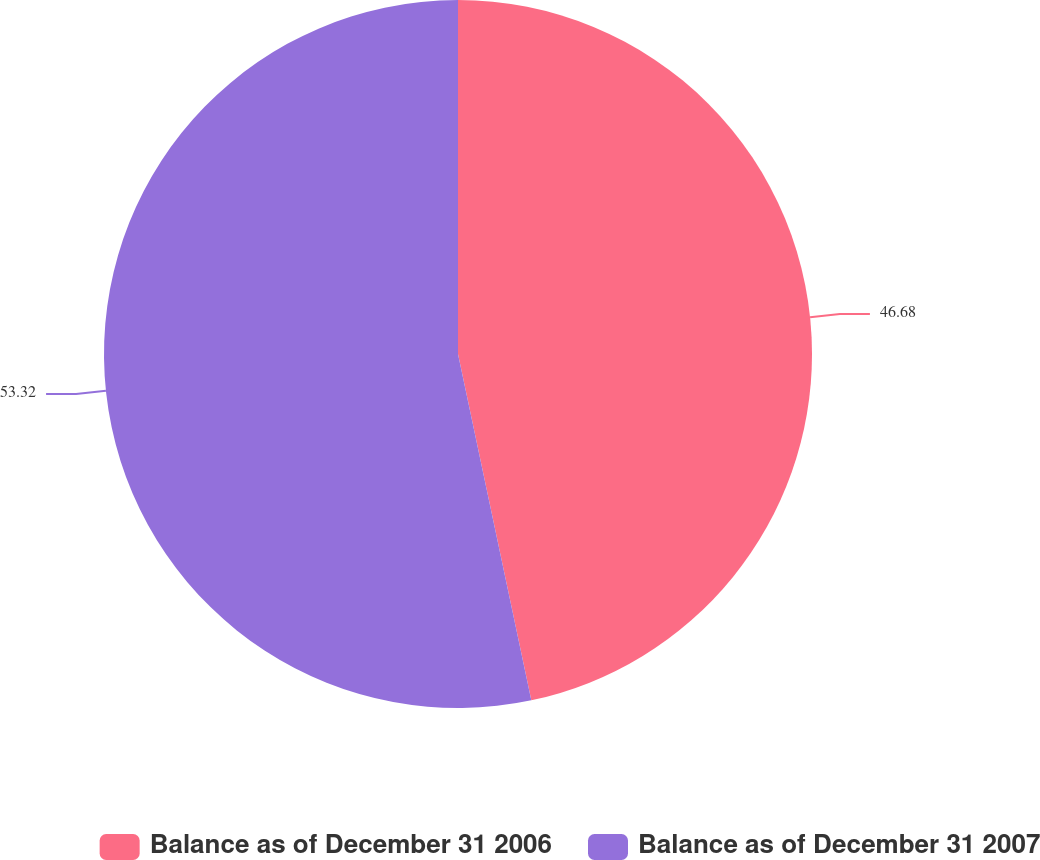Convert chart to OTSL. <chart><loc_0><loc_0><loc_500><loc_500><pie_chart><fcel>Balance as of December 31 2006<fcel>Balance as of December 31 2007<nl><fcel>46.68%<fcel>53.32%<nl></chart> 